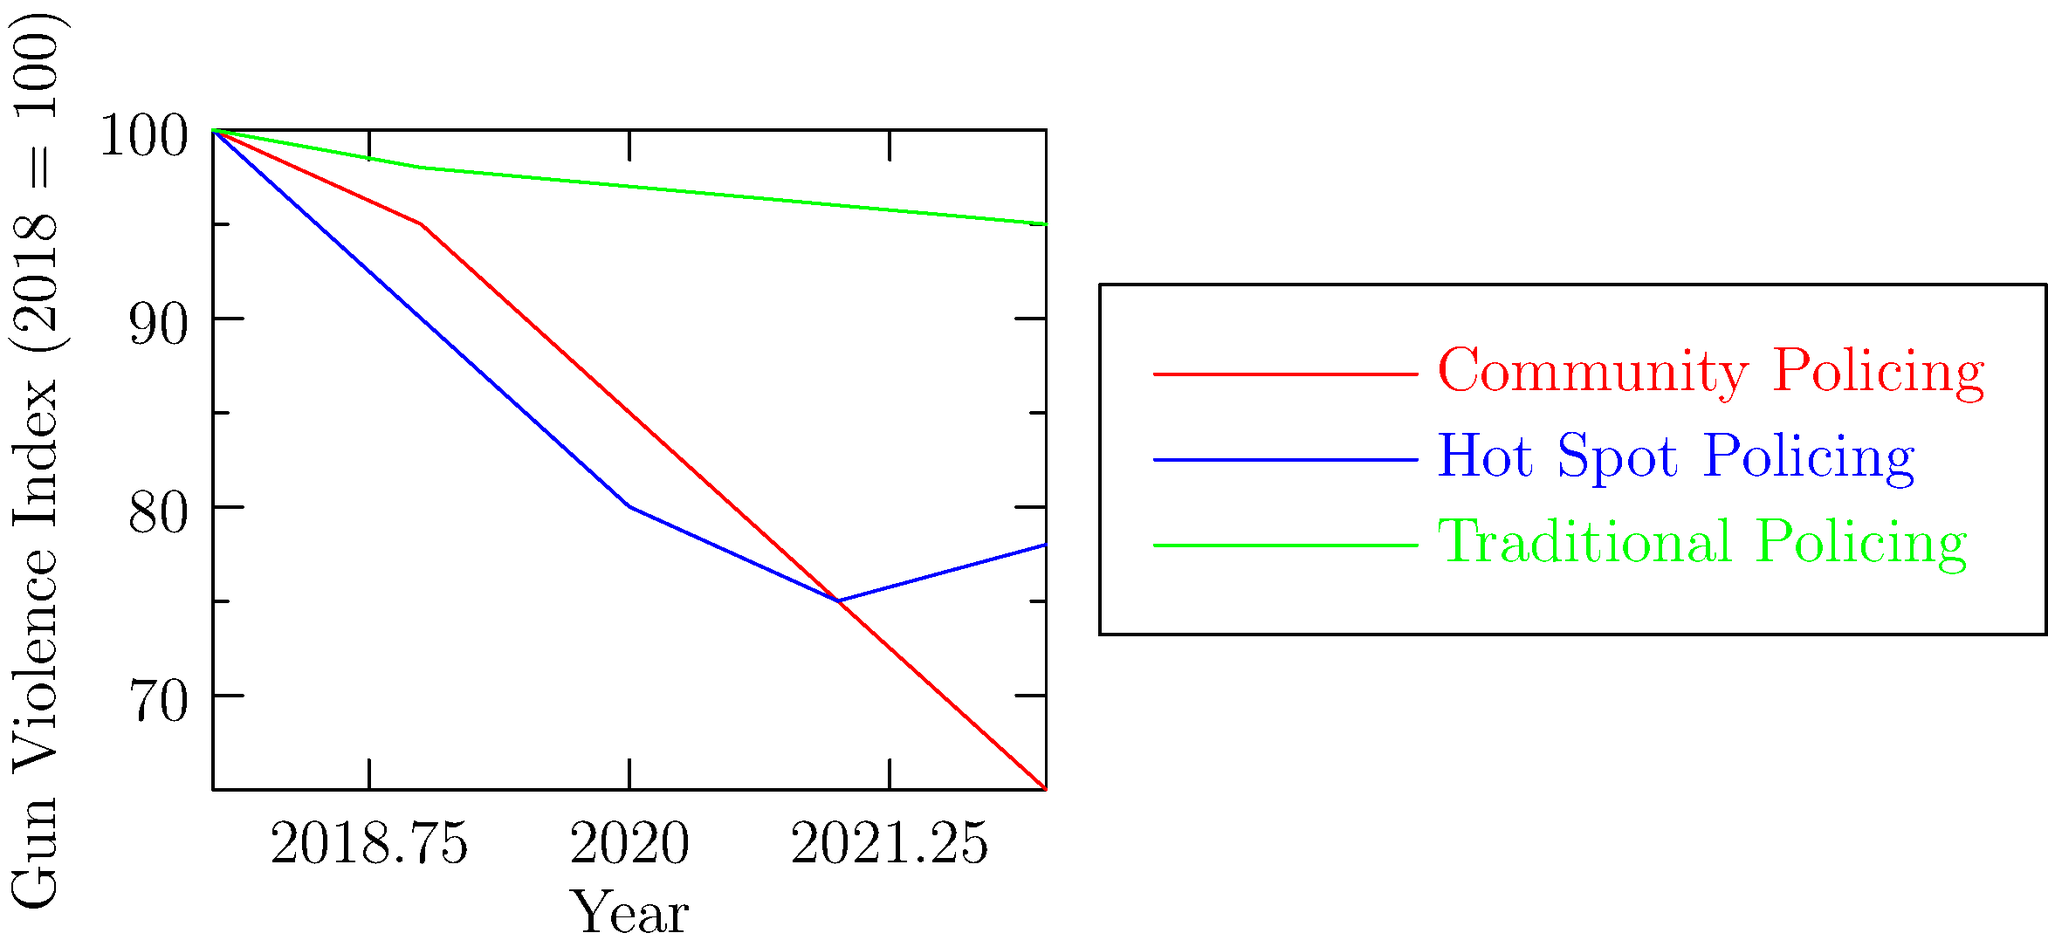Based on the line graph showing the Gun Violence Index for different policing strategies from 2018 to 2022, which strategy appears to be the most effective in reducing gun violence over the five-year period? To determine the most effective strategy in reducing gun violence, we need to analyze the trends for each policing approach:

1. Traditional Policing (green line):
   - Starts at 100 in 2018
   - Shows minimal decrease, ending at about 95 in 2022
   - Reduction: Approximately 5%

2. Hot Spot Policing (blue line):
   - Starts at 100 in 2018
   - Decreases to about 75 by 2021, but slightly increases to 78 in 2022
   - Reduction: Approximately 22%

3. Community Policing (red line):
   - Starts at 100 in 2018
   - Shows consistent decrease, ending at about 65 in 2022
   - Reduction: Approximately 35%

Comparing the three strategies:
- Traditional Policing shows the least reduction in gun violence.
- Hot Spot Policing shows significant improvement but has a slight increase in the last year.
- Community Policing demonstrates the most consistent and substantial decrease over the five-year period.

Therefore, based on this data, Community Policing appears to be the most effective strategy in reducing gun violence from 2018 to 2022.
Answer: Community Policing 